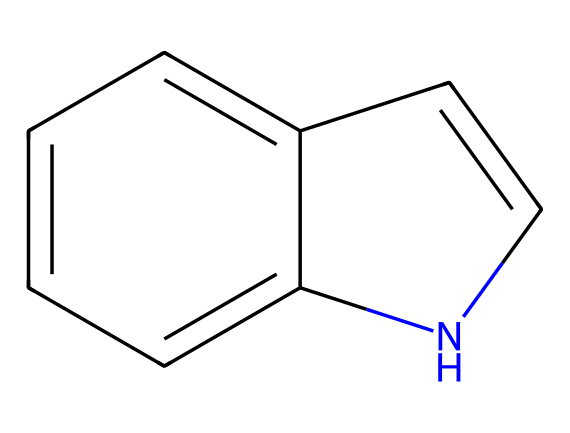How many carbon atoms are in indole? The given SMILES representation indicates a structure with a total of eight carbon atoms, represented as 'c' in the SMILES notation.
Answer: eight What functional group is present in indole? Indole contains a nitrogen atom within a six-membered aromatic ring, which classifies it as a heterocyclic aromatic compound.
Answer: nitrogen How many double bonds are in the structure of indole? The aromatic rings in indole indicate the presence of double bonds, specifically there are five double bonds based on the pi-bonding in the aromatic system.
Answer: five What type of compound is indole classified as? Indole is classified as an aromatic compound due to the delocalized pi electrons within its cyclic structure and the presence of alternating double bonds.
Answer: aromatic Which element differentiates this compound from a standard aromatic hydrocarbon? The nitrogen atom in the structure is the differentiating feature since it introduces a heteroatom, making it a heterocyclic compound rather than a standard aromatic hydrocarbon.
Answer: nitrogen How many rings are present in the structure of indole? The indole structure contains two fused rings, a benzene ring and a pyrrole ring, which creates its unique bicyclic system.
Answer: two 